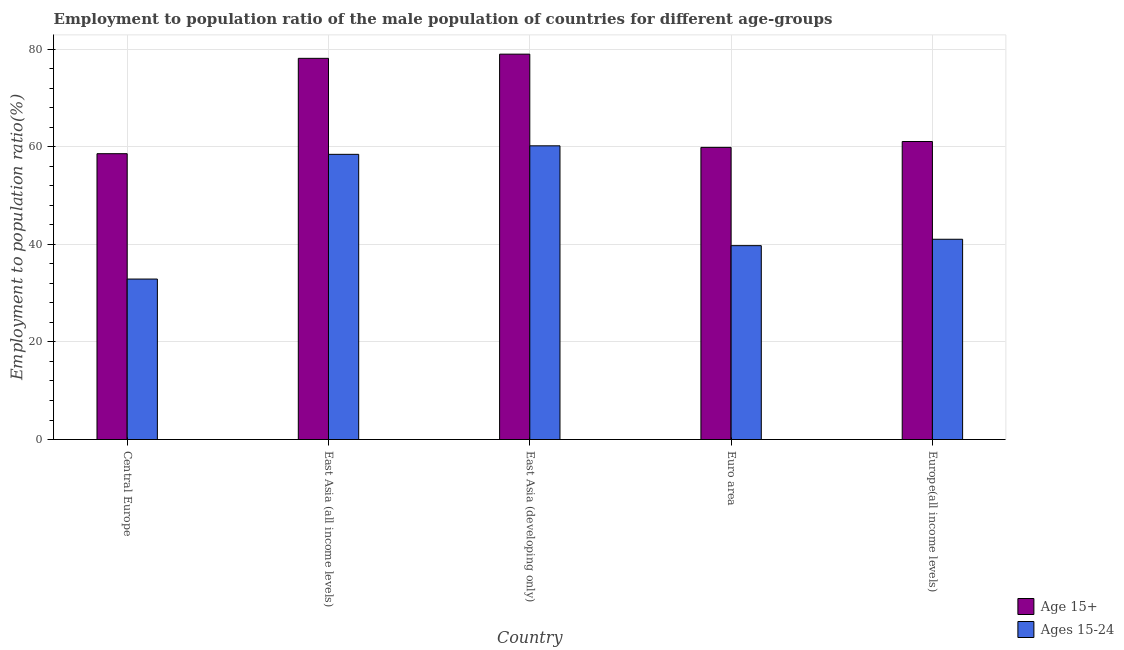How many groups of bars are there?
Your answer should be very brief. 5. Are the number of bars per tick equal to the number of legend labels?
Provide a succinct answer. Yes. Are the number of bars on each tick of the X-axis equal?
Ensure brevity in your answer.  Yes. How many bars are there on the 2nd tick from the left?
Your answer should be very brief. 2. What is the label of the 5th group of bars from the left?
Make the answer very short. Europe(all income levels). In how many cases, is the number of bars for a given country not equal to the number of legend labels?
Offer a terse response. 0. What is the employment to population ratio(age 15-24) in Europe(all income levels)?
Your answer should be very brief. 41.06. Across all countries, what is the maximum employment to population ratio(age 15-24)?
Keep it short and to the point. 60.22. Across all countries, what is the minimum employment to population ratio(age 15+)?
Your answer should be compact. 58.61. In which country was the employment to population ratio(age 15-24) maximum?
Your response must be concise. East Asia (developing only). In which country was the employment to population ratio(age 15+) minimum?
Your answer should be very brief. Central Europe. What is the total employment to population ratio(age 15+) in the graph?
Offer a very short reply. 336.78. What is the difference between the employment to population ratio(age 15-24) in Central Europe and that in Euro area?
Give a very brief answer. -6.85. What is the difference between the employment to population ratio(age 15-24) in East Asia (all income levels) and the employment to population ratio(age 15+) in Central Europe?
Your answer should be very brief. -0.13. What is the average employment to population ratio(age 15-24) per country?
Your response must be concise. 46.48. What is the difference between the employment to population ratio(age 15-24) and employment to population ratio(age 15+) in East Asia (all income levels)?
Keep it short and to the point. -19.68. What is the ratio of the employment to population ratio(age 15+) in Euro area to that in Europe(all income levels)?
Your answer should be compact. 0.98. Is the employment to population ratio(age 15+) in Central Europe less than that in East Asia (all income levels)?
Your answer should be compact. Yes. What is the difference between the highest and the second highest employment to population ratio(age 15+)?
Offer a very short reply. 0.86. What is the difference between the highest and the lowest employment to population ratio(age 15-24)?
Ensure brevity in your answer.  27.32. Is the sum of the employment to population ratio(age 15+) in Central Europe and East Asia (all income levels) greater than the maximum employment to population ratio(age 15-24) across all countries?
Make the answer very short. Yes. What does the 2nd bar from the left in Euro area represents?
Your answer should be very brief. Ages 15-24. What does the 1st bar from the right in Euro area represents?
Ensure brevity in your answer.  Ages 15-24. How many bars are there?
Provide a short and direct response. 10. How many countries are there in the graph?
Make the answer very short. 5. Does the graph contain any zero values?
Provide a short and direct response. No. Does the graph contain grids?
Provide a succinct answer. Yes. Where does the legend appear in the graph?
Provide a succinct answer. Bottom right. How many legend labels are there?
Provide a succinct answer. 2. What is the title of the graph?
Make the answer very short. Employment to population ratio of the male population of countries for different age-groups. Does "Resident" appear as one of the legend labels in the graph?
Offer a very short reply. No. What is the Employment to population ratio(%) of Age 15+ in Central Europe?
Your response must be concise. 58.61. What is the Employment to population ratio(%) of Ages 15-24 in Central Europe?
Give a very brief answer. 32.9. What is the Employment to population ratio(%) of Age 15+ in East Asia (all income levels)?
Your response must be concise. 78.16. What is the Employment to population ratio(%) in Ages 15-24 in East Asia (all income levels)?
Provide a succinct answer. 58.47. What is the Employment to population ratio(%) of Age 15+ in East Asia (developing only)?
Give a very brief answer. 79.02. What is the Employment to population ratio(%) of Ages 15-24 in East Asia (developing only)?
Provide a succinct answer. 60.22. What is the Employment to population ratio(%) in Age 15+ in Euro area?
Your response must be concise. 59.9. What is the Employment to population ratio(%) in Ages 15-24 in Euro area?
Your answer should be compact. 39.75. What is the Employment to population ratio(%) of Age 15+ in Europe(all income levels)?
Your answer should be very brief. 61.1. What is the Employment to population ratio(%) in Ages 15-24 in Europe(all income levels)?
Give a very brief answer. 41.06. Across all countries, what is the maximum Employment to population ratio(%) of Age 15+?
Make the answer very short. 79.02. Across all countries, what is the maximum Employment to population ratio(%) of Ages 15-24?
Offer a very short reply. 60.22. Across all countries, what is the minimum Employment to population ratio(%) of Age 15+?
Offer a very short reply. 58.61. Across all countries, what is the minimum Employment to population ratio(%) in Ages 15-24?
Offer a very short reply. 32.9. What is the total Employment to population ratio(%) in Age 15+ in the graph?
Offer a terse response. 336.78. What is the total Employment to population ratio(%) in Ages 15-24 in the graph?
Give a very brief answer. 232.41. What is the difference between the Employment to population ratio(%) in Age 15+ in Central Europe and that in East Asia (all income levels)?
Provide a succinct answer. -19.55. What is the difference between the Employment to population ratio(%) of Ages 15-24 in Central Europe and that in East Asia (all income levels)?
Provide a short and direct response. -25.57. What is the difference between the Employment to population ratio(%) in Age 15+ in Central Europe and that in East Asia (developing only)?
Offer a terse response. -20.41. What is the difference between the Employment to population ratio(%) in Ages 15-24 in Central Europe and that in East Asia (developing only)?
Your answer should be compact. -27.32. What is the difference between the Employment to population ratio(%) of Age 15+ in Central Europe and that in Euro area?
Give a very brief answer. -1.29. What is the difference between the Employment to population ratio(%) in Ages 15-24 in Central Europe and that in Euro area?
Your answer should be very brief. -6.85. What is the difference between the Employment to population ratio(%) of Age 15+ in Central Europe and that in Europe(all income levels)?
Provide a short and direct response. -2.5. What is the difference between the Employment to population ratio(%) in Ages 15-24 in Central Europe and that in Europe(all income levels)?
Provide a succinct answer. -8.16. What is the difference between the Employment to population ratio(%) in Age 15+ in East Asia (all income levels) and that in East Asia (developing only)?
Give a very brief answer. -0.86. What is the difference between the Employment to population ratio(%) of Ages 15-24 in East Asia (all income levels) and that in East Asia (developing only)?
Offer a terse response. -1.74. What is the difference between the Employment to population ratio(%) in Age 15+ in East Asia (all income levels) and that in Euro area?
Offer a terse response. 18.26. What is the difference between the Employment to population ratio(%) of Ages 15-24 in East Asia (all income levels) and that in Euro area?
Provide a succinct answer. 18.72. What is the difference between the Employment to population ratio(%) in Age 15+ in East Asia (all income levels) and that in Europe(all income levels)?
Give a very brief answer. 17.05. What is the difference between the Employment to population ratio(%) of Ages 15-24 in East Asia (all income levels) and that in Europe(all income levels)?
Provide a short and direct response. 17.41. What is the difference between the Employment to population ratio(%) in Age 15+ in East Asia (developing only) and that in Euro area?
Your response must be concise. 19.12. What is the difference between the Employment to population ratio(%) of Ages 15-24 in East Asia (developing only) and that in Euro area?
Your answer should be compact. 20.47. What is the difference between the Employment to population ratio(%) in Age 15+ in East Asia (developing only) and that in Europe(all income levels)?
Give a very brief answer. 17.91. What is the difference between the Employment to population ratio(%) of Ages 15-24 in East Asia (developing only) and that in Europe(all income levels)?
Provide a succinct answer. 19.16. What is the difference between the Employment to population ratio(%) in Age 15+ in Euro area and that in Europe(all income levels)?
Keep it short and to the point. -1.21. What is the difference between the Employment to population ratio(%) of Ages 15-24 in Euro area and that in Europe(all income levels)?
Provide a succinct answer. -1.31. What is the difference between the Employment to population ratio(%) of Age 15+ in Central Europe and the Employment to population ratio(%) of Ages 15-24 in East Asia (all income levels)?
Keep it short and to the point. 0.13. What is the difference between the Employment to population ratio(%) in Age 15+ in Central Europe and the Employment to population ratio(%) in Ages 15-24 in East Asia (developing only)?
Your answer should be compact. -1.61. What is the difference between the Employment to population ratio(%) of Age 15+ in Central Europe and the Employment to population ratio(%) of Ages 15-24 in Euro area?
Provide a succinct answer. 18.85. What is the difference between the Employment to population ratio(%) of Age 15+ in Central Europe and the Employment to population ratio(%) of Ages 15-24 in Europe(all income levels)?
Give a very brief answer. 17.55. What is the difference between the Employment to population ratio(%) of Age 15+ in East Asia (all income levels) and the Employment to population ratio(%) of Ages 15-24 in East Asia (developing only)?
Your answer should be compact. 17.94. What is the difference between the Employment to population ratio(%) of Age 15+ in East Asia (all income levels) and the Employment to population ratio(%) of Ages 15-24 in Euro area?
Offer a terse response. 38.41. What is the difference between the Employment to population ratio(%) in Age 15+ in East Asia (all income levels) and the Employment to population ratio(%) in Ages 15-24 in Europe(all income levels)?
Your response must be concise. 37.1. What is the difference between the Employment to population ratio(%) in Age 15+ in East Asia (developing only) and the Employment to population ratio(%) in Ages 15-24 in Euro area?
Offer a terse response. 39.27. What is the difference between the Employment to population ratio(%) in Age 15+ in East Asia (developing only) and the Employment to population ratio(%) in Ages 15-24 in Europe(all income levels)?
Ensure brevity in your answer.  37.96. What is the difference between the Employment to population ratio(%) of Age 15+ in Euro area and the Employment to population ratio(%) of Ages 15-24 in Europe(all income levels)?
Give a very brief answer. 18.84. What is the average Employment to population ratio(%) in Age 15+ per country?
Make the answer very short. 67.36. What is the average Employment to population ratio(%) of Ages 15-24 per country?
Make the answer very short. 46.48. What is the difference between the Employment to population ratio(%) of Age 15+ and Employment to population ratio(%) of Ages 15-24 in Central Europe?
Offer a very short reply. 25.71. What is the difference between the Employment to population ratio(%) of Age 15+ and Employment to population ratio(%) of Ages 15-24 in East Asia (all income levels)?
Your response must be concise. 19.68. What is the difference between the Employment to population ratio(%) in Age 15+ and Employment to population ratio(%) in Ages 15-24 in East Asia (developing only)?
Offer a very short reply. 18.8. What is the difference between the Employment to population ratio(%) of Age 15+ and Employment to population ratio(%) of Ages 15-24 in Euro area?
Make the answer very short. 20.15. What is the difference between the Employment to population ratio(%) of Age 15+ and Employment to population ratio(%) of Ages 15-24 in Europe(all income levels)?
Your response must be concise. 20.04. What is the ratio of the Employment to population ratio(%) of Age 15+ in Central Europe to that in East Asia (all income levels)?
Provide a succinct answer. 0.75. What is the ratio of the Employment to population ratio(%) of Ages 15-24 in Central Europe to that in East Asia (all income levels)?
Your answer should be compact. 0.56. What is the ratio of the Employment to population ratio(%) in Age 15+ in Central Europe to that in East Asia (developing only)?
Give a very brief answer. 0.74. What is the ratio of the Employment to population ratio(%) of Ages 15-24 in Central Europe to that in East Asia (developing only)?
Offer a very short reply. 0.55. What is the ratio of the Employment to population ratio(%) of Age 15+ in Central Europe to that in Euro area?
Offer a terse response. 0.98. What is the ratio of the Employment to population ratio(%) of Ages 15-24 in Central Europe to that in Euro area?
Your answer should be very brief. 0.83. What is the ratio of the Employment to population ratio(%) of Age 15+ in Central Europe to that in Europe(all income levels)?
Give a very brief answer. 0.96. What is the ratio of the Employment to population ratio(%) in Ages 15-24 in Central Europe to that in Europe(all income levels)?
Make the answer very short. 0.8. What is the ratio of the Employment to population ratio(%) of Age 15+ in East Asia (all income levels) to that in Euro area?
Your response must be concise. 1.3. What is the ratio of the Employment to population ratio(%) in Ages 15-24 in East Asia (all income levels) to that in Euro area?
Provide a succinct answer. 1.47. What is the ratio of the Employment to population ratio(%) in Age 15+ in East Asia (all income levels) to that in Europe(all income levels)?
Offer a very short reply. 1.28. What is the ratio of the Employment to population ratio(%) in Ages 15-24 in East Asia (all income levels) to that in Europe(all income levels)?
Your response must be concise. 1.42. What is the ratio of the Employment to population ratio(%) in Age 15+ in East Asia (developing only) to that in Euro area?
Your response must be concise. 1.32. What is the ratio of the Employment to population ratio(%) in Ages 15-24 in East Asia (developing only) to that in Euro area?
Make the answer very short. 1.51. What is the ratio of the Employment to population ratio(%) of Age 15+ in East Asia (developing only) to that in Europe(all income levels)?
Ensure brevity in your answer.  1.29. What is the ratio of the Employment to population ratio(%) in Ages 15-24 in East Asia (developing only) to that in Europe(all income levels)?
Keep it short and to the point. 1.47. What is the ratio of the Employment to population ratio(%) in Age 15+ in Euro area to that in Europe(all income levels)?
Give a very brief answer. 0.98. What is the ratio of the Employment to population ratio(%) of Ages 15-24 in Euro area to that in Europe(all income levels)?
Keep it short and to the point. 0.97. What is the difference between the highest and the second highest Employment to population ratio(%) in Age 15+?
Make the answer very short. 0.86. What is the difference between the highest and the second highest Employment to population ratio(%) of Ages 15-24?
Keep it short and to the point. 1.74. What is the difference between the highest and the lowest Employment to population ratio(%) in Age 15+?
Provide a succinct answer. 20.41. What is the difference between the highest and the lowest Employment to population ratio(%) of Ages 15-24?
Give a very brief answer. 27.32. 